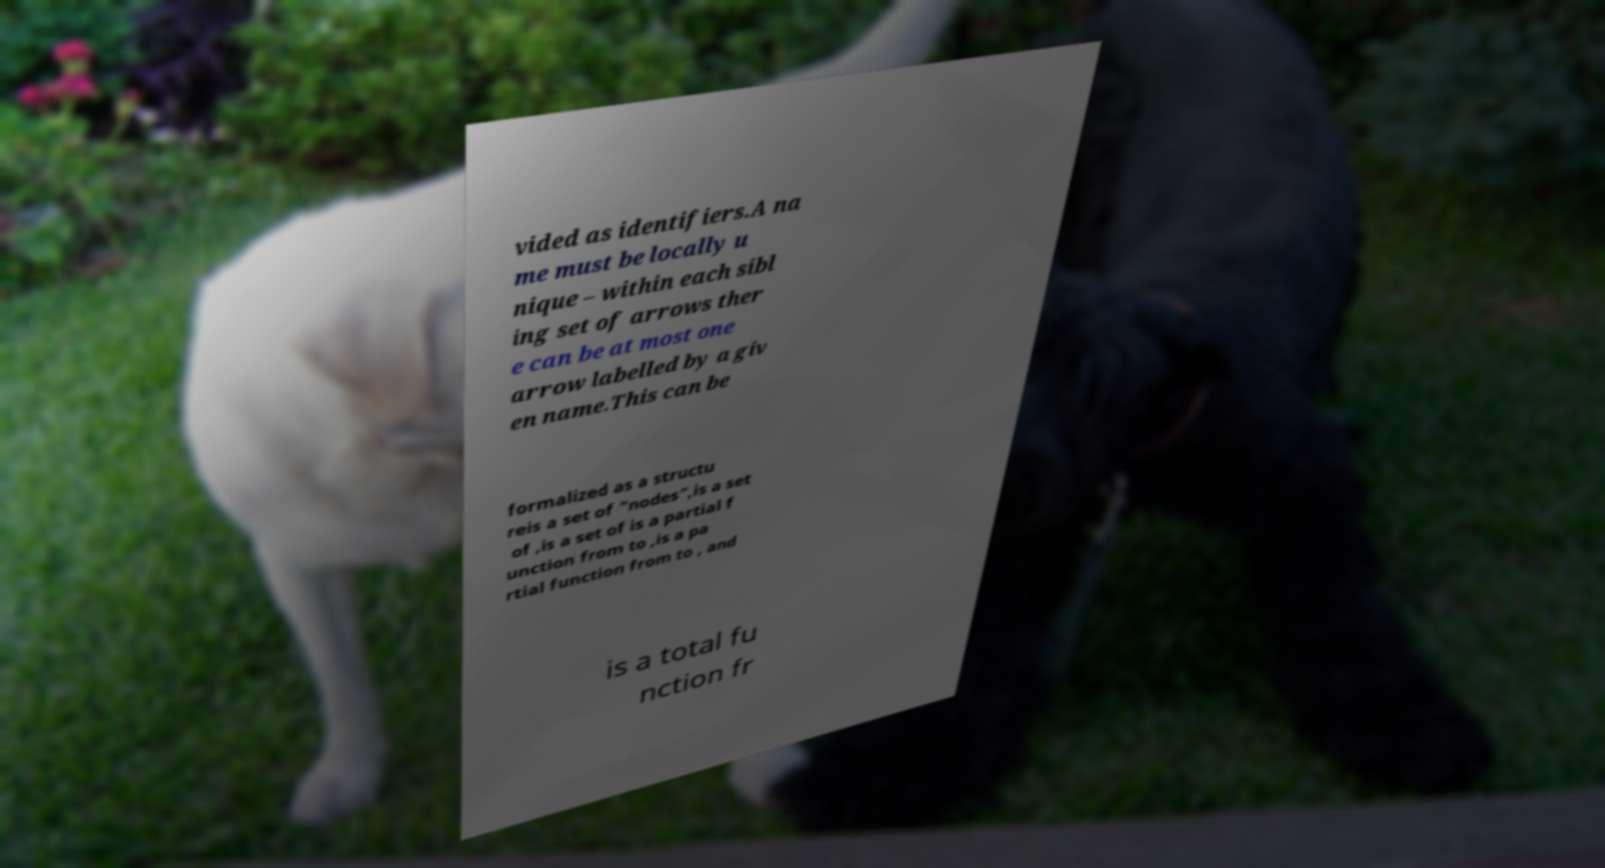I need the written content from this picture converted into text. Can you do that? vided as identifiers.A na me must be locally u nique – within each sibl ing set of arrows ther e can be at most one arrow labelled by a giv en name.This can be formalized as a structu reis a set of "nodes",is a set of ,is a set of is a partial f unction from to ,is a pa rtial function from to , and is a total fu nction fr 